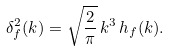<formula> <loc_0><loc_0><loc_500><loc_500>\delta _ { f } ^ { 2 } ( k ) = \sqrt { \frac { 2 } { \pi } } \, k ^ { 3 } \, h _ { f } ( k ) .</formula> 